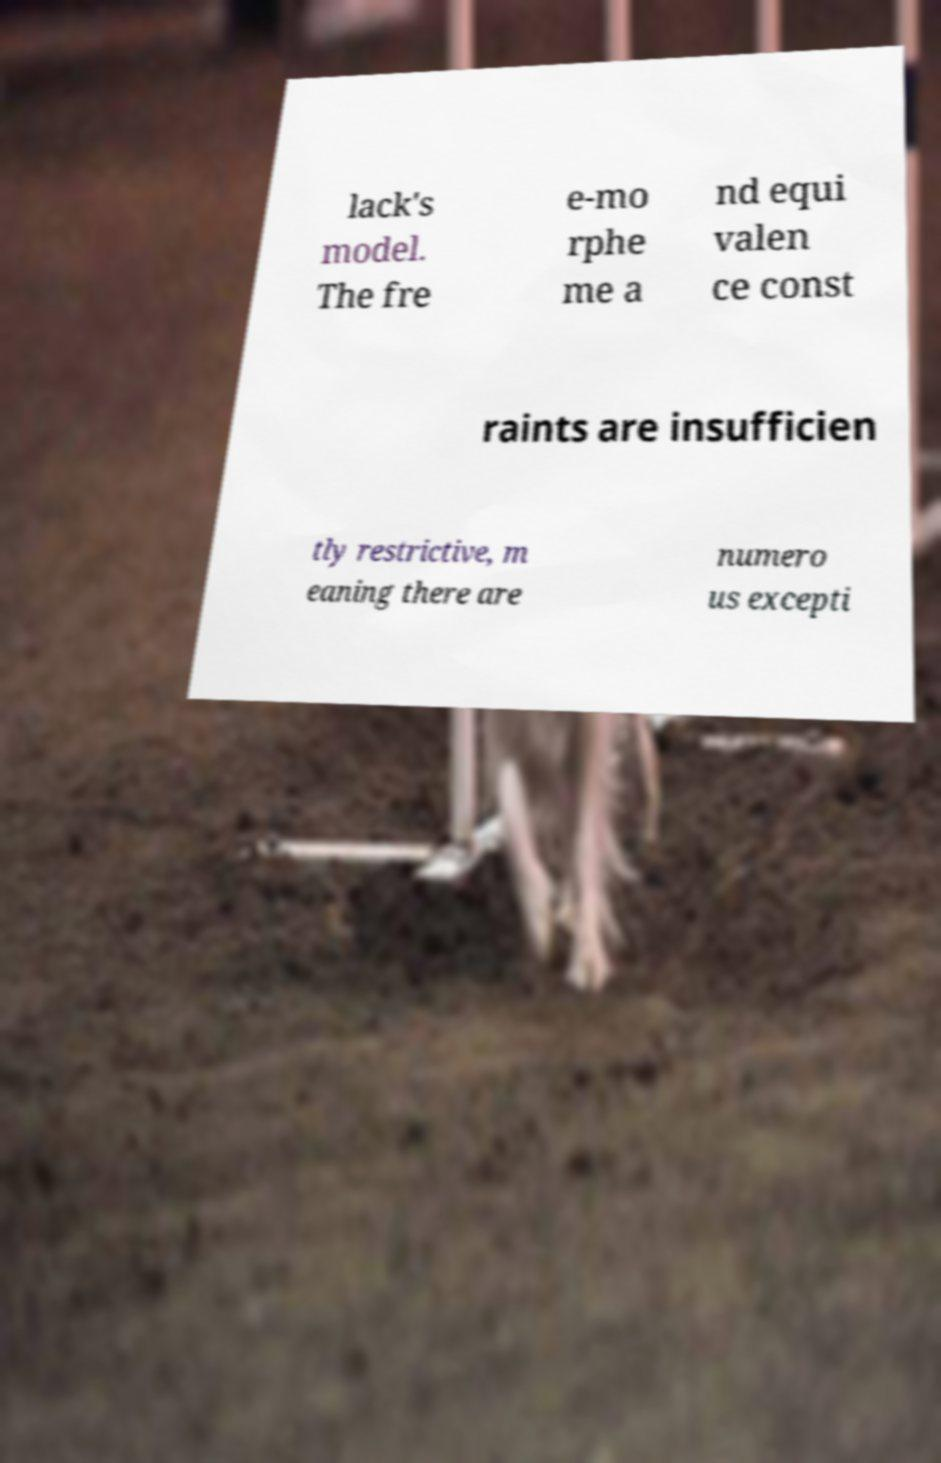Can you read and provide the text displayed in the image?This photo seems to have some interesting text. Can you extract and type it out for me? lack's model. The fre e-mo rphe me a nd equi valen ce const raints are insufficien tly restrictive, m eaning there are numero us excepti 